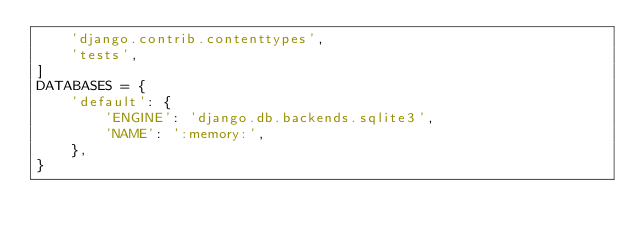Convert code to text. <code><loc_0><loc_0><loc_500><loc_500><_Python_>    'django.contrib.contenttypes',
    'tests',
]
DATABASES = {
    'default': {
        'ENGINE': 'django.db.backends.sqlite3',
        'NAME': ':memory:',
    },
}
</code> 